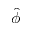<formula> <loc_0><loc_0><loc_500><loc_500>\hat { \phi }</formula> 